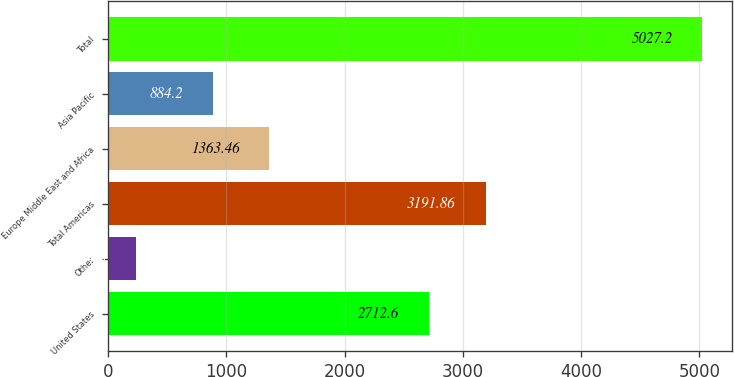Convert chart to OTSL. <chart><loc_0><loc_0><loc_500><loc_500><bar_chart><fcel>United States<fcel>Other<fcel>Total Americas<fcel>Europe Middle East and Africa<fcel>Asia Pacific<fcel>Total<nl><fcel>2712.6<fcel>234.6<fcel>3191.86<fcel>1363.46<fcel>884.2<fcel>5027.2<nl></chart> 